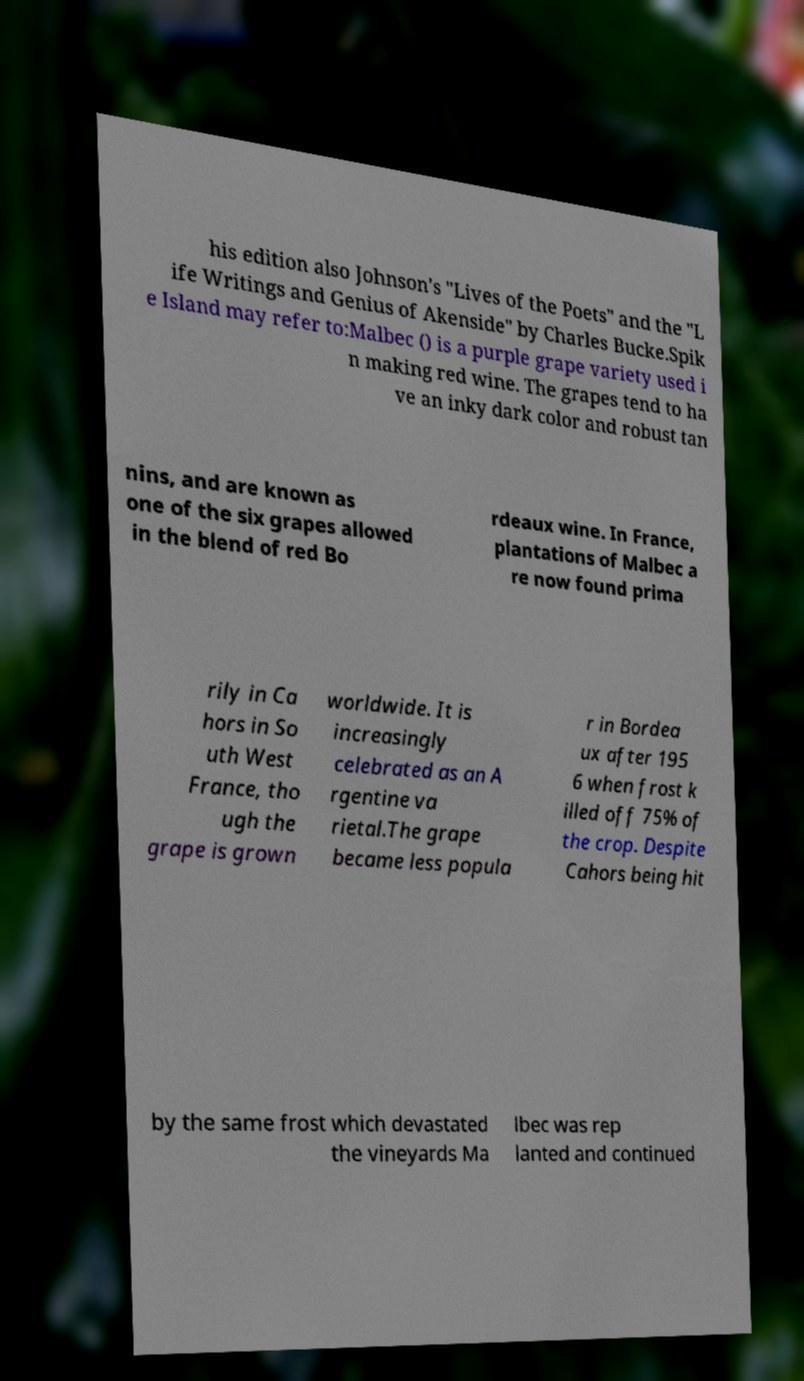Can you accurately transcribe the text from the provided image for me? his edition also Johnson's "Lives of the Poets" and the "L ife Writings and Genius of Akenside" by Charles Bucke.Spik e Island may refer to:Malbec () is a purple grape variety used i n making red wine. The grapes tend to ha ve an inky dark color and robust tan nins, and are known as one of the six grapes allowed in the blend of red Bo rdeaux wine. In France, plantations of Malbec a re now found prima rily in Ca hors in So uth West France, tho ugh the grape is grown worldwide. It is increasingly celebrated as an A rgentine va rietal.The grape became less popula r in Bordea ux after 195 6 when frost k illed off 75% of the crop. Despite Cahors being hit by the same frost which devastated the vineyards Ma lbec was rep lanted and continued 